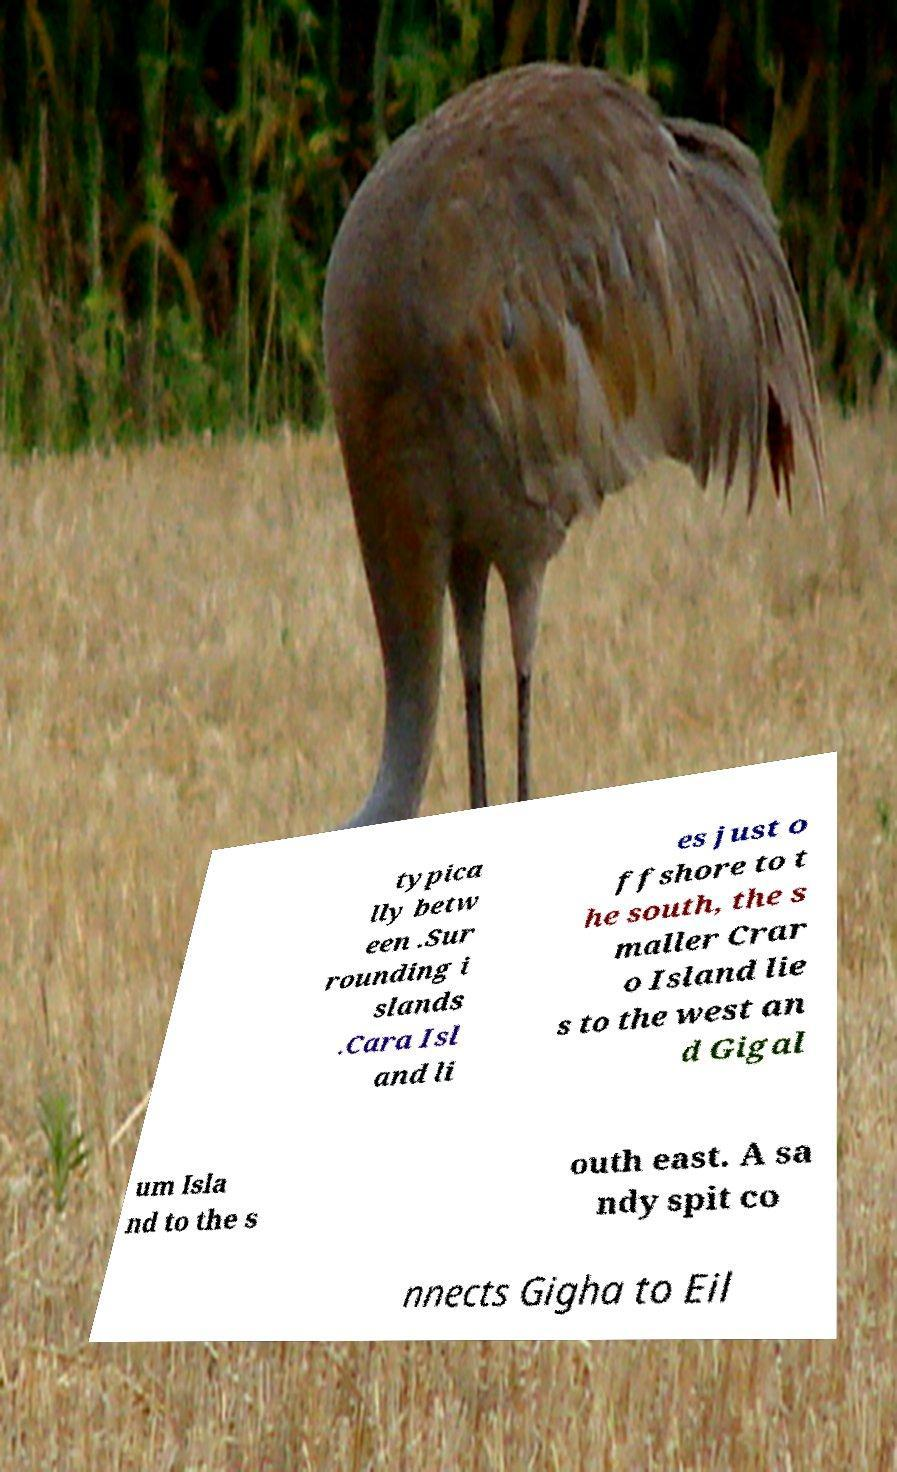Please read and relay the text visible in this image. What does it say? typica lly betw een .Sur rounding i slands .Cara Isl and li es just o ffshore to t he south, the s maller Crar o Island lie s to the west an d Gigal um Isla nd to the s outh east. A sa ndy spit co nnects Gigha to Eil 